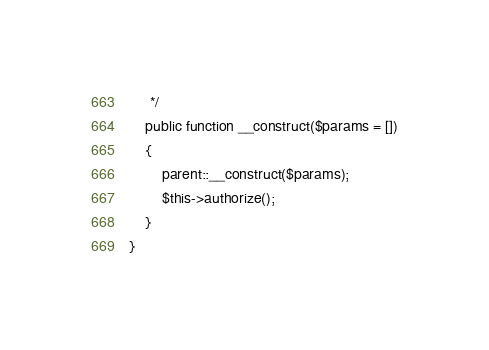Convert code to text. <code><loc_0><loc_0><loc_500><loc_500><_PHP_>     */
    public function __construct($params = [])
    {
        parent::__construct($params);
        $this->authorize();
    }
}
</code> 